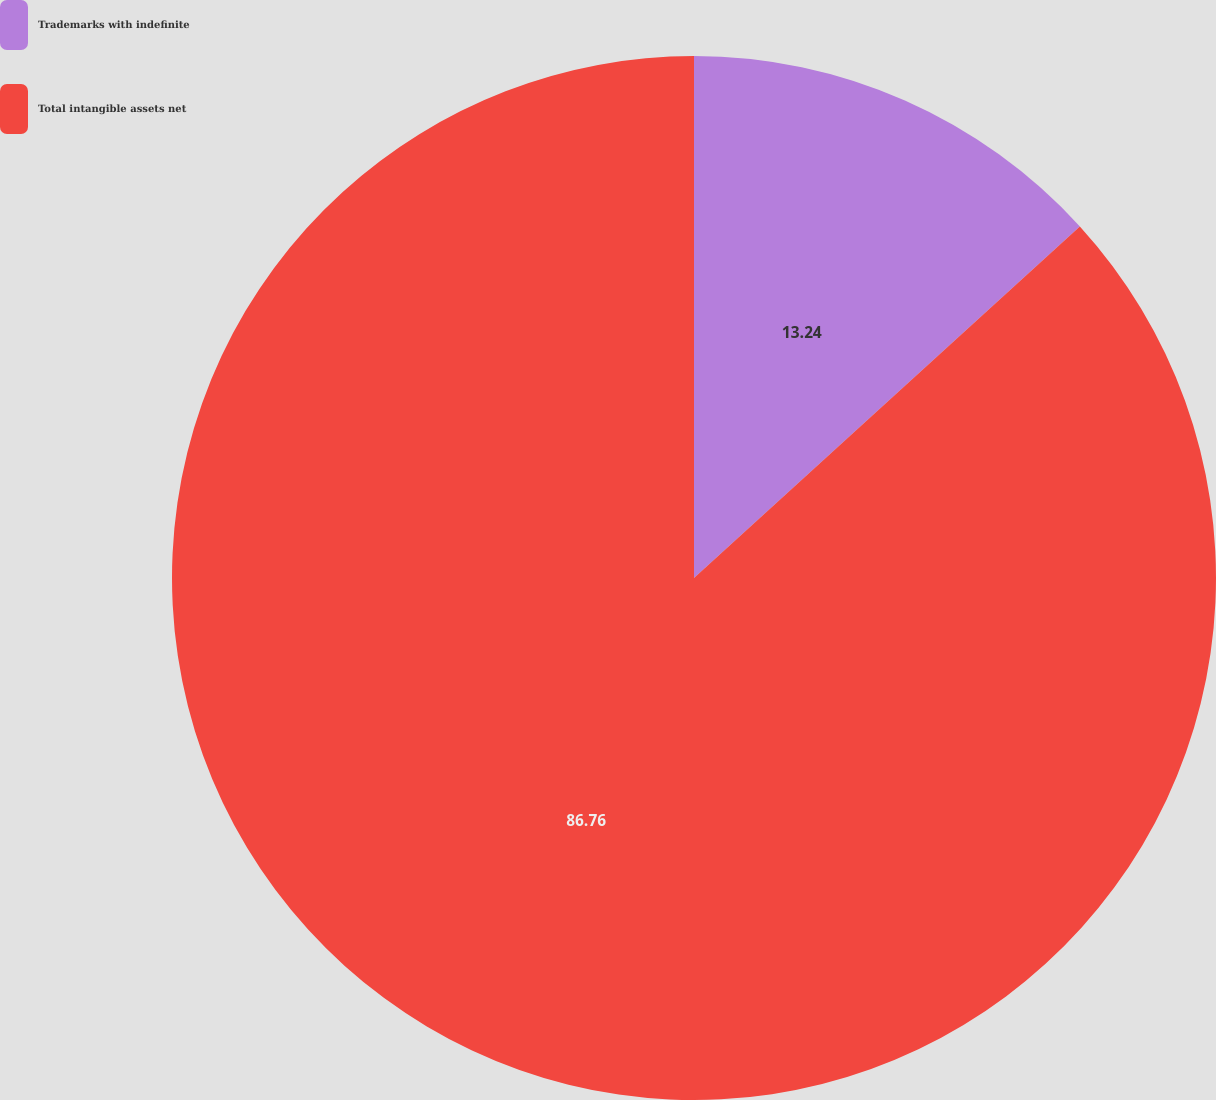Convert chart to OTSL. <chart><loc_0><loc_0><loc_500><loc_500><pie_chart><fcel>Trademarks with indefinite<fcel>Total intangible assets net<nl><fcel>13.24%<fcel>86.76%<nl></chart> 